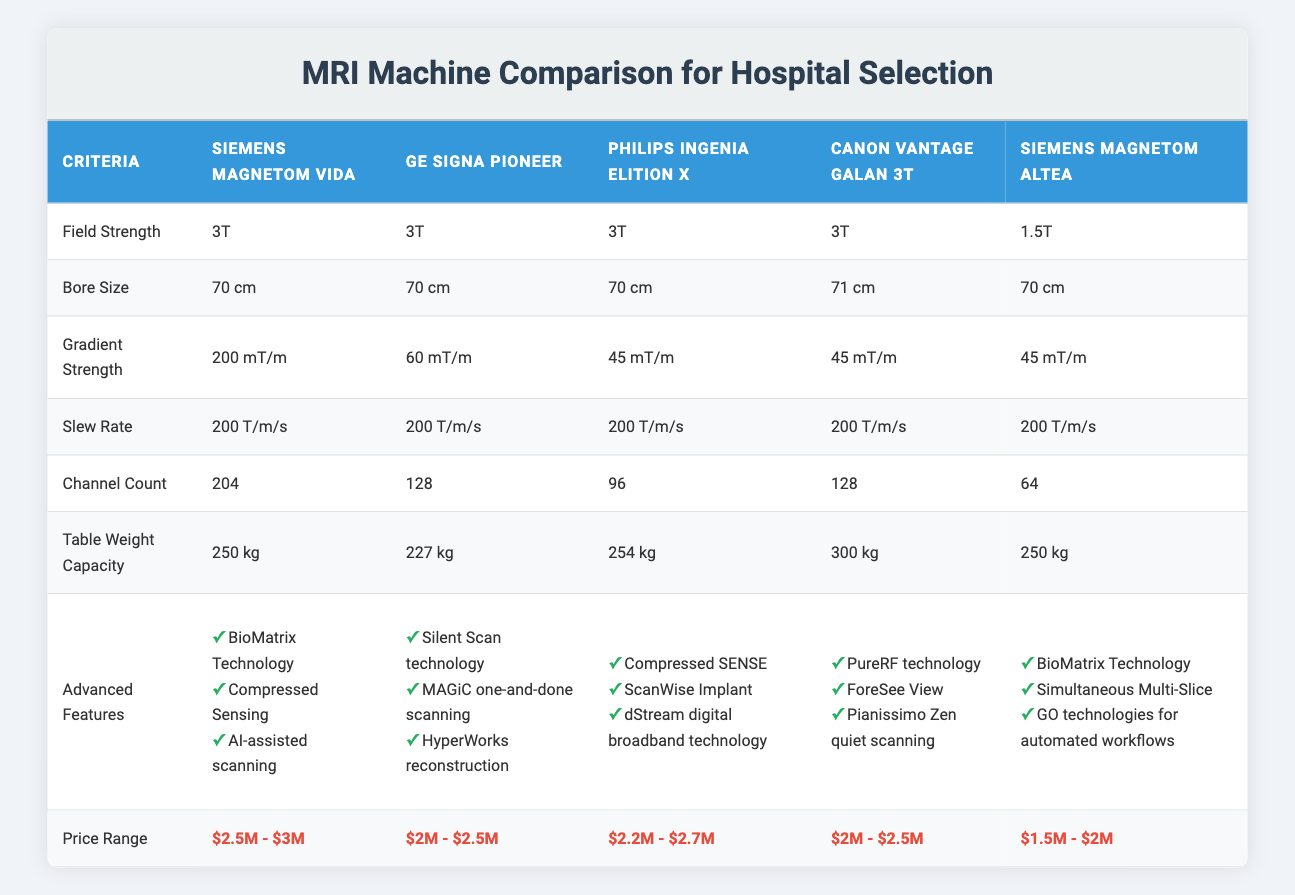What is the field strength of the Siemens MAGNETOM Vida? The table shows that the field strength of the Siemens MAGNETOM Vida is listed directly under its respective column, which is 3T.
Answer: 3T Which MRI machine has the highest channel count? By comparing the channel counts in the table, the Siemens MAGNETOM Vida has a channel count of 204, which is higher than the other listed machines.
Answer: Siemens MAGNETOM Vida True or false: The Canon Vantage Galan 3T has a higher table weight capacity than the GE SIGNA Pioneer. Looking at the table, the Canon Vantage Galan 3T has a table weight capacity of 300 kg, while the GE SIGNA Pioneer has 227 kg. Since 300 kg is greater than 227 kg, the statement is true.
Answer: True Which machines share the same bore size, and what is that size? The bore size of all four machines—Siemens MAGNETOM Vida, GE SIGNA Pioneer, Philips Ingenia Elition X, and Siemens MAGNETOM Altea—is 70 cm, while the Canon Vantage Galan 3T has a bore size of 71 cm.
Answer: 70 cm What is the price range difference between the most expensive and the least expensive MRI machine? The most expensive machine is the Siemens MAGNETOM Vida with a price range of $2.5M - $3M. The least expensive is the Siemens MAGNETOM Altea at $1.5M - $2M. Calculating the upper limits: 3M - 2M = 1M, and the lower limits: 2.5M - 1.5M = 1M. The price range difference is therefore $1M at both limits.
Answer: $1M What advanced feature is unique to the GE SIGNA Pioneer? The advanced features for each MRI machine are listed in the table. Upon examination, "Silent Scan technology" is available only for the GE SIGNA Pioneer, with no other machine sharing this feature.
Answer: Silent Scan technology Which MRI machines have a slew rate of 200 T/m/s, and how does this compare to the others? The table shows that all four machines—Siemens MAGNETOM Vida, GE SIGNA Pioneer, Philips Ingenia Elition X, and Canon Vantage Galan 3T—have a consistent slew rate of 200 T/m/s. The Siemens MAGNETOM Altea also shares this slew rate, indicating all listed machines provide the same performance parameter in this aspect.
Answer: All machines Identify the machine with the lowest gradient strength and explain why it's significant. The Philips Ingenia Elition X, Canon Vantage Galan 3T, and Siemens MAGNETOM Altea all have a gradient strength of 45 mT/m. This lower gradient strength compared to the others (200 mT/m for the Siemens MAGNETOM Vida and 60 mT/m for the GE SIGNA Pioneer) could affect imaging speed and resolution, making this machine less suitable for high-demand imaging needs.
Answer: Philips Ingenia Elition X, Canon Vantage Galan 3T, Siemens MAGNETOM Altea How many advanced features does the Siemens MAGNETOM Altea offer compared to the Philips Ingenia Elition X? The Siemens MAGNETOM Altea has three advanced features: BioMatrix Technology, Simultaneous Multi-Slice, and GO technologies for automated workflows. The Philips Ingenia Elition X also has three advanced features: Compressed SENSE, ScanWise Implant, and dStream digital broadband technology. Therefore, both machines offer an equal number of advanced features.
Answer: 3 